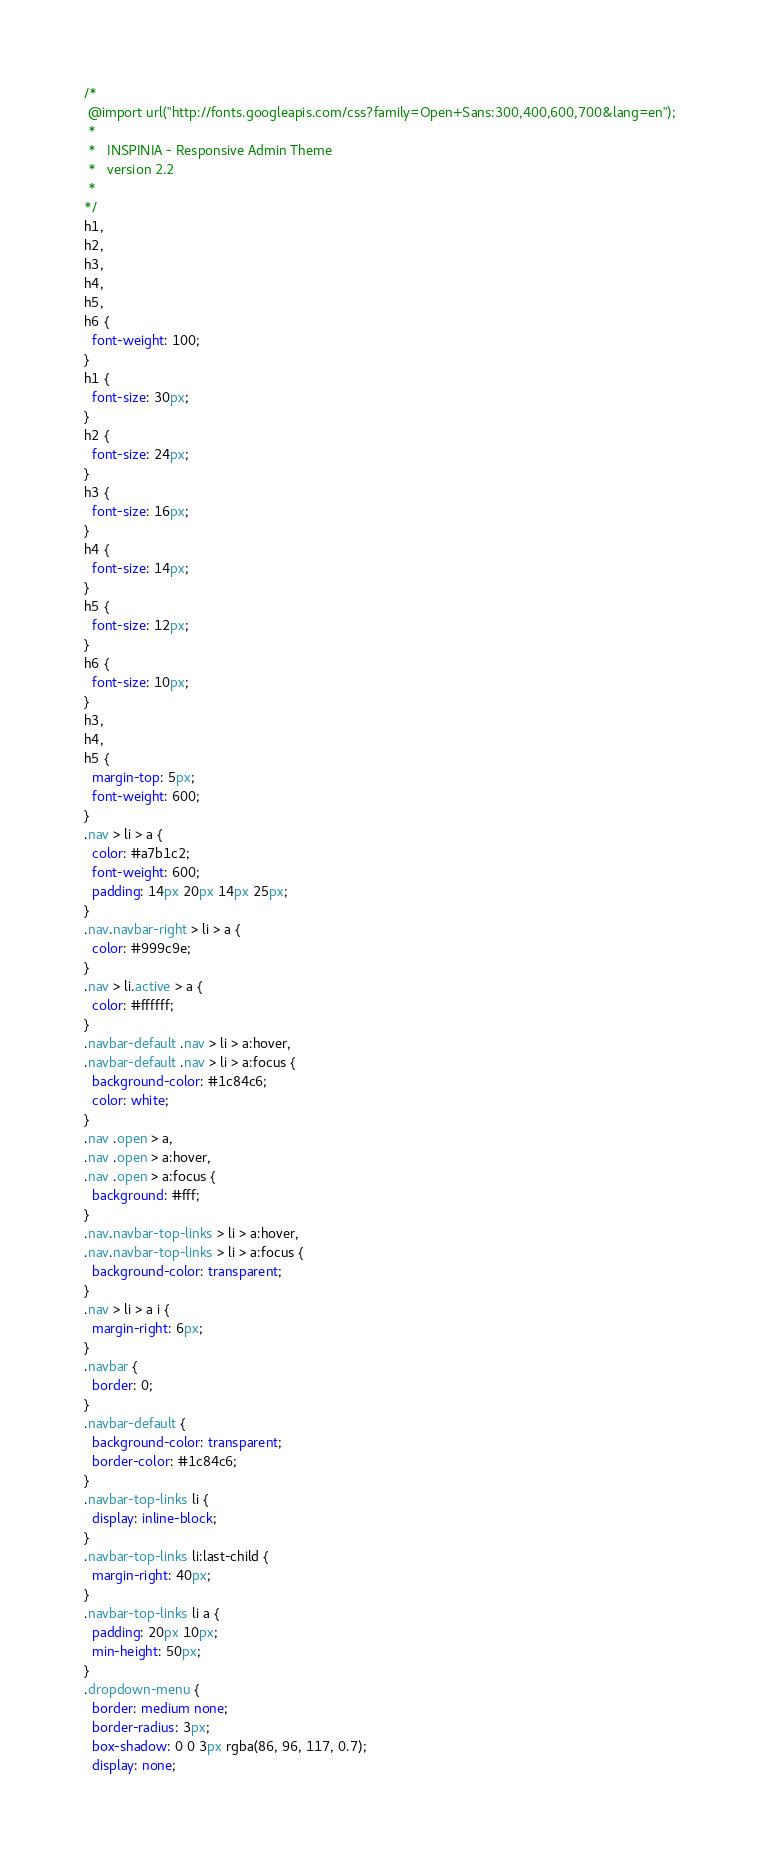<code> <loc_0><loc_0><loc_500><loc_500><_CSS_>
/*
 @import url("http://fonts.googleapis.com/css?family=Open+Sans:300,400,600,700&lang=en");
 *
 *   INSPINIA - Responsive Admin Theme
 *   version 2.2
 *
*/
h1,
h2,
h3,
h4,
h5,
h6 {
  font-weight: 100;
}
h1 {
  font-size: 30px;
}
h2 {
  font-size: 24px;
}
h3 {
  font-size: 16px;
}
h4 {
  font-size: 14px;
}
h5 {
  font-size: 12px;
}
h6 {
  font-size: 10px;
}
h3,
h4,
h5 {
  margin-top: 5px;
  font-weight: 600;
}
.nav > li > a {
  color: #a7b1c2;
  font-weight: 600;
  padding: 14px 20px 14px 25px;
}
.nav.navbar-right > li > a {
  color: #999c9e;
}
.nav > li.active > a {
  color: #ffffff;
}
.navbar-default .nav > li > a:hover,
.navbar-default .nav > li > a:focus {
  background-color: #1c84c6;
  color: white;
}
.nav .open > a,
.nav .open > a:hover,
.nav .open > a:focus {
  background: #fff;
}
.nav.navbar-top-links > li > a:hover,
.nav.navbar-top-links > li > a:focus {
  background-color: transparent;
}
.nav > li > a i {
  margin-right: 6px;
}
.navbar {
  border: 0;
}
.navbar-default {
  background-color: transparent;
  border-color: #1c84c6;
}
.navbar-top-links li {
  display: inline-block;
}
.navbar-top-links li:last-child {
  margin-right: 40px;
}
.navbar-top-links li a {
  padding: 20px 10px;
  min-height: 50px;
}
.dropdown-menu {
  border: medium none;
  border-radius: 3px;
  box-shadow: 0 0 3px rgba(86, 96, 117, 0.7);
  display: none;</code> 